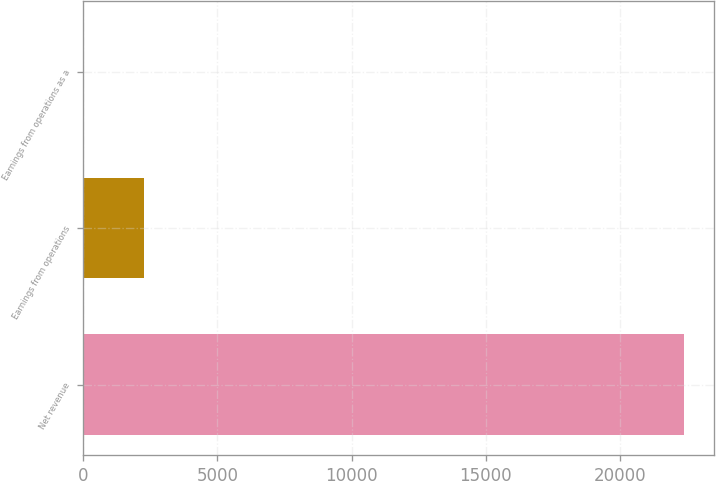Convert chart. <chart><loc_0><loc_0><loc_500><loc_500><bar_chart><fcel>Net revenue<fcel>Earnings from operations<fcel>Earnings from operations as a<nl><fcel>22398<fcel>2243.04<fcel>3.6<nl></chart> 